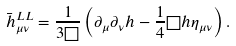<formula> <loc_0><loc_0><loc_500><loc_500>\bar { h } ^ { L L } _ { \mu \nu } = \frac { 1 } { 3 \Box } \left ( \partial _ { \mu } \partial _ { \nu } h - \frac { 1 } { 4 } \Box h \eta _ { \mu \nu } \right ) .</formula> 